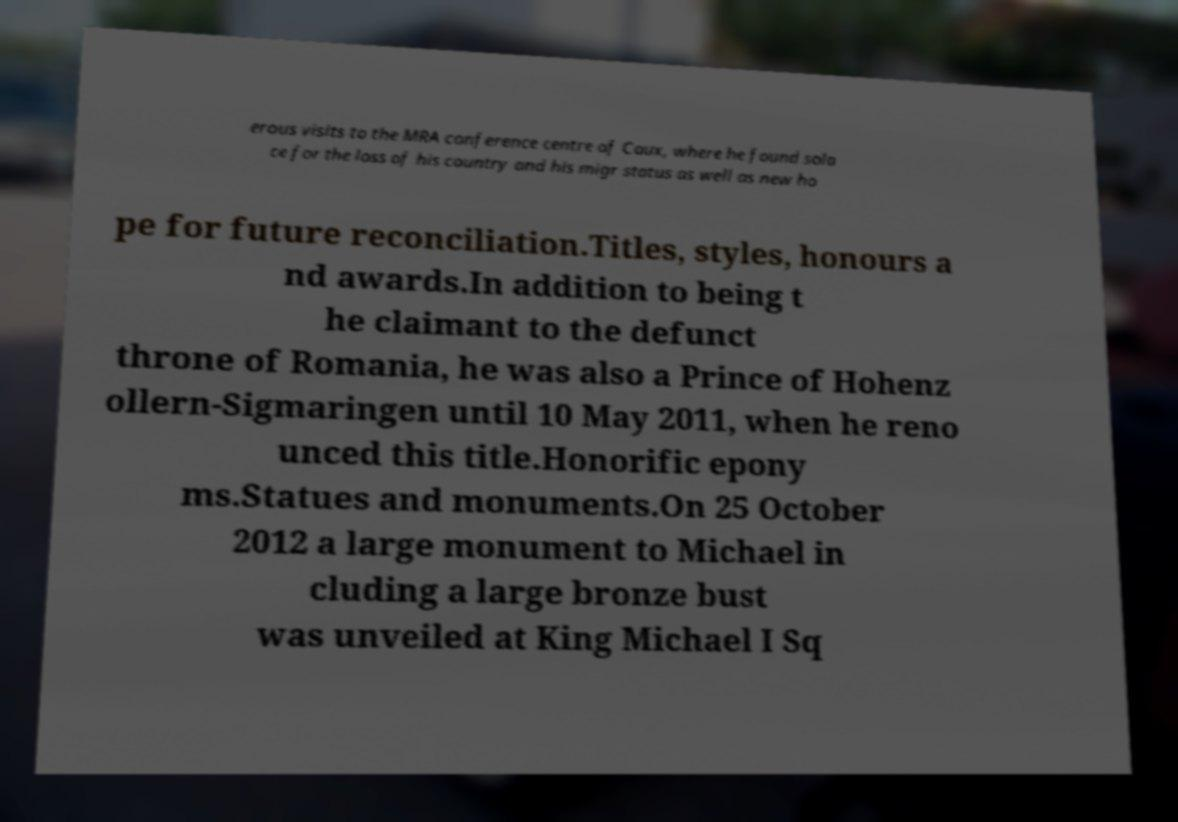Could you extract and type out the text from this image? erous visits to the MRA conference centre of Caux, where he found sola ce for the loss of his country and his migr status as well as new ho pe for future reconciliation.Titles, styles, honours a nd awards.In addition to being t he claimant to the defunct throne of Romania, he was also a Prince of Hohenz ollern-Sigmaringen until 10 May 2011, when he reno unced this title.Honorific epony ms.Statues and monuments.On 25 October 2012 a large monument to Michael in cluding a large bronze bust was unveiled at King Michael I Sq 